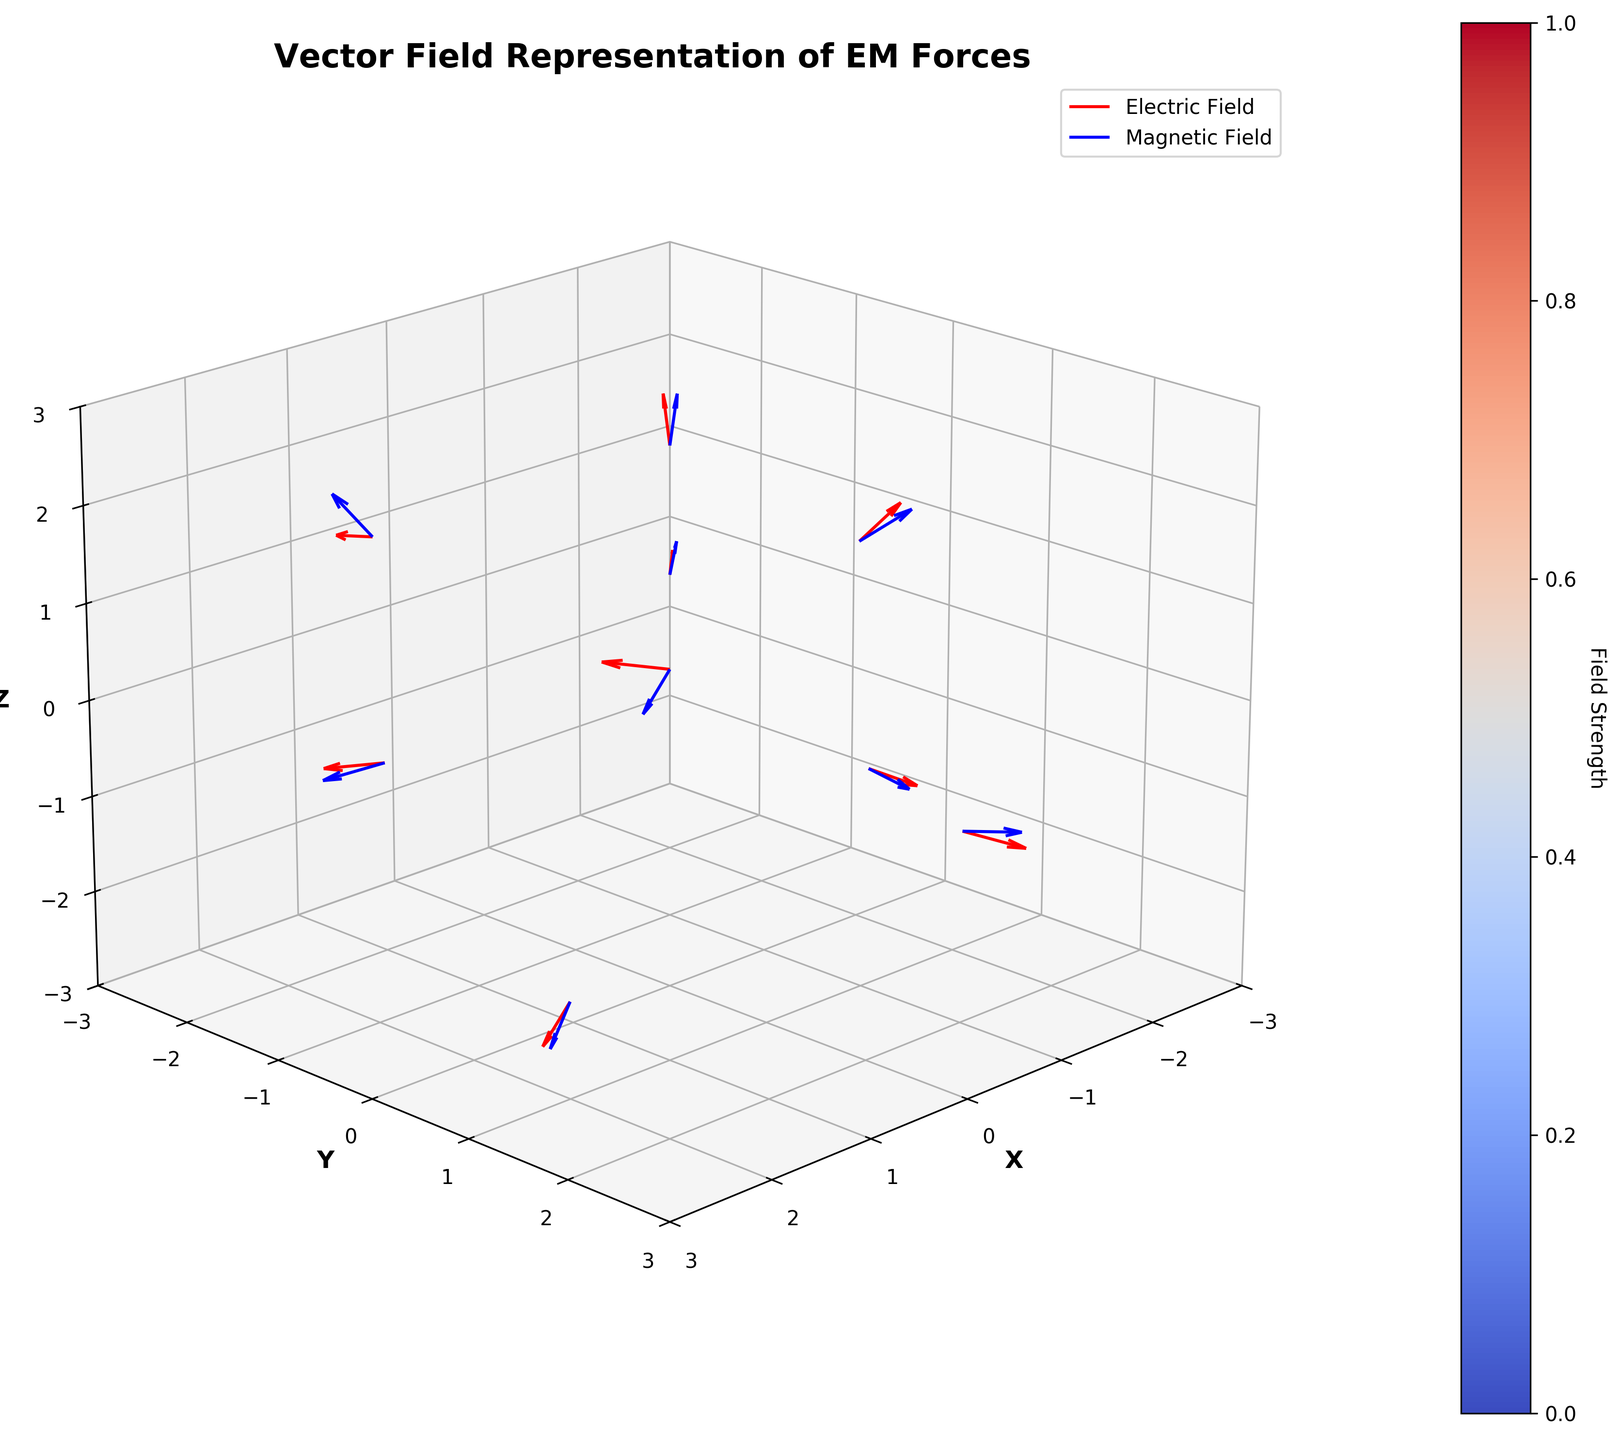What is the title of the figure? The title of the figure is positioned at the top of the plot and labeled as ‘Vector Field Representation of EM Forces’.
Answer: Vector Field Representation of EM Forces How many data points are represented in the figure? By examining the number of vectors in the plot, each originating from a different (x, y, z) coordinate, you can count a total of 10 data points.
Answer: 10 Which field uses the color red for representation? The electric field vectors are drawn in red, as indicated by the legend in the upper right corner of the plot.
Answer: Electric Field What vector is located at point (2, -1, 2) for the magnetic field? By referring to the data provided, the magnetic field vector at (2, -1, 2) is represented as (0.2, -0.3, 0.5).
Answer: (0.2, -0.3, 0.5) What are the axis limits for the Z-axis in the figure? The Z-axis range is observed to be from -3 to 3, as indicated by the axis ticks and the axis limit settings.
Answer: -3 to 3 Are the vectors normalized in the plot? Yes, the vectors are normalized, which can be inferred from the code setting 'normalize=True' and visually confirmed by the consistent length of vectors in the plot.
Answer: Yes At which point does the electric field have the highest magnitude? The highest magnitude of the electric field can be deduced from the longest red vectors in the plot. By examining the data, the point (2, 1, -2) has electric field components (4.2, 1.5, -2.4). Their squared sum, √(4.2² + 1.5² + 2.4²), yields the highest value among the data points.
Answer: (2, 1, -2) Compare the electric field and magnetic field strengths at point (1,1,1). Which one is greater? Calculate the magnitudes: Electric field components are (2.5, -1.8, 0.7) and magnetic field components are (0.3, 0.1, -0.2). Magnitude of E: √(2.5² + (-1.8)² + 0.7²) ≈ 3.1. Magnitude of B: √(0.3² + 0.1² + (-0.2)²) ≈ 0.374. The Electric field (3.1) is greater than the Magnetic field (0.374).
Answer: Electric field If we sum up the X-component of all electric field vectors, what is the total? Sum the X-components of the electric field vectors from all data points: 0 + 2.5 + (-1.2) + 3.7 + (-2.9) + 1.4 + (-0.6) + 4.2 + 0.2 + (-3.5) = 3.8
Answer: 3.8 In which region (quadrant) of the XY-plane can you find the point with the highest positive Z-component in the magnetic field? Examine data to find the point with the highest positive Z-component: Point (-1, -1, 2) has magnetic Z-component 0.6. This point lies in the third quadrant (negative X and negative Y) of the XY-plane.
Answer: Third quadrant 